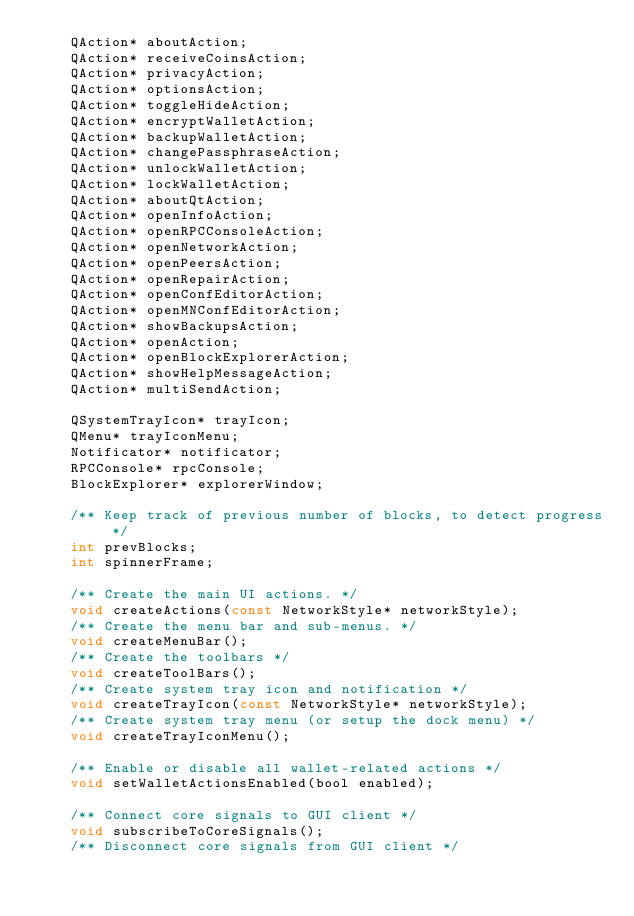<code> <loc_0><loc_0><loc_500><loc_500><_C_>    QAction* aboutAction;
    QAction* receiveCoinsAction;
    QAction* privacyAction;
    QAction* optionsAction;
    QAction* toggleHideAction;
    QAction* encryptWalletAction;
    QAction* backupWalletAction;
    QAction* changePassphraseAction;
    QAction* unlockWalletAction;
    QAction* lockWalletAction;
    QAction* aboutQtAction;
    QAction* openInfoAction;
    QAction* openRPCConsoleAction;
    QAction* openNetworkAction;
    QAction* openPeersAction;
    QAction* openRepairAction;
    QAction* openConfEditorAction;
    QAction* openMNConfEditorAction;
    QAction* showBackupsAction;
    QAction* openAction;
    QAction* openBlockExplorerAction;
    QAction* showHelpMessageAction;
    QAction* multiSendAction;

    QSystemTrayIcon* trayIcon;
    QMenu* trayIconMenu;
    Notificator* notificator;
    RPCConsole* rpcConsole;
    BlockExplorer* explorerWindow;

    /** Keep track of previous number of blocks, to detect progress */
    int prevBlocks;
    int spinnerFrame;

    /** Create the main UI actions. */
    void createActions(const NetworkStyle* networkStyle);
    /** Create the menu bar and sub-menus. */
    void createMenuBar();
    /** Create the toolbars */
    void createToolBars();
    /** Create system tray icon and notification */
    void createTrayIcon(const NetworkStyle* networkStyle);
    /** Create system tray menu (or setup the dock menu) */
    void createTrayIconMenu();

    /** Enable or disable all wallet-related actions */
    void setWalletActionsEnabled(bool enabled);

    /** Connect core signals to GUI client */
    void subscribeToCoreSignals();
    /** Disconnect core signals from GUI client */</code> 